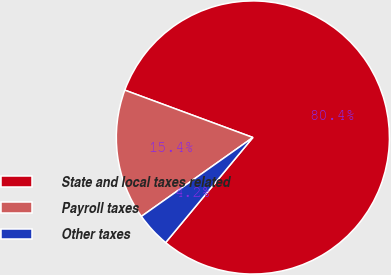<chart> <loc_0><loc_0><loc_500><loc_500><pie_chart><fcel>State and local taxes related<fcel>Payroll taxes<fcel>Other taxes<nl><fcel>80.39%<fcel>15.44%<fcel>4.17%<nl></chart> 